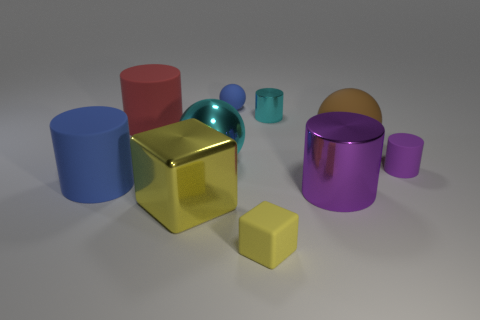Subtract all cyan cylinders. How many cylinders are left? 4 Subtract all yellow cylinders. Subtract all red balls. How many cylinders are left? 5 Subtract all balls. How many objects are left? 7 Subtract all small blue cylinders. Subtract all blue objects. How many objects are left? 8 Add 5 shiny objects. How many shiny objects are left? 9 Add 1 large rubber blocks. How many large rubber blocks exist? 1 Subtract 1 blue balls. How many objects are left? 9 